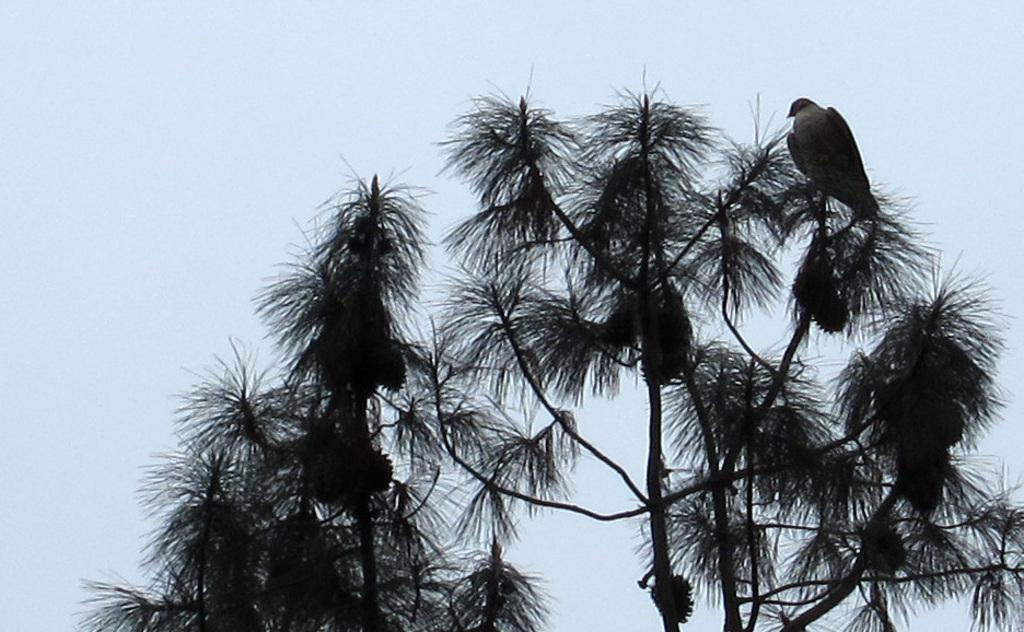What type of animal can be seen in the image? There is a bird in the image. Where is the bird located? The bird is on the branch of a tree. What part of the natural environment is visible in the image? The sky is visible in the image. What type of dress is the bird wearing in the image? Birds do not wear dresses, so this question cannot be answered based on the image. 